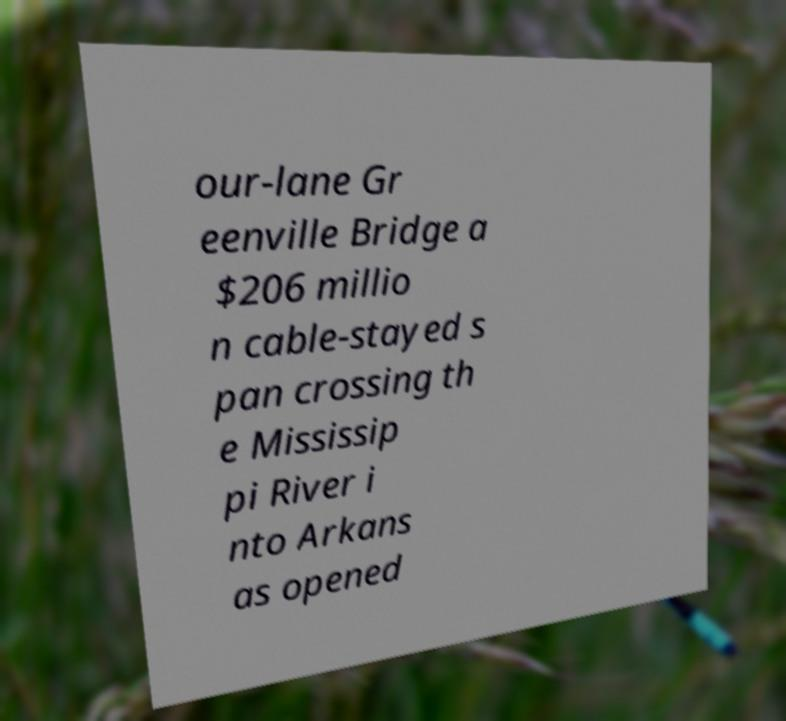There's text embedded in this image that I need extracted. Can you transcribe it verbatim? our-lane Gr eenville Bridge a $206 millio n cable-stayed s pan crossing th e Mississip pi River i nto Arkans as opened 